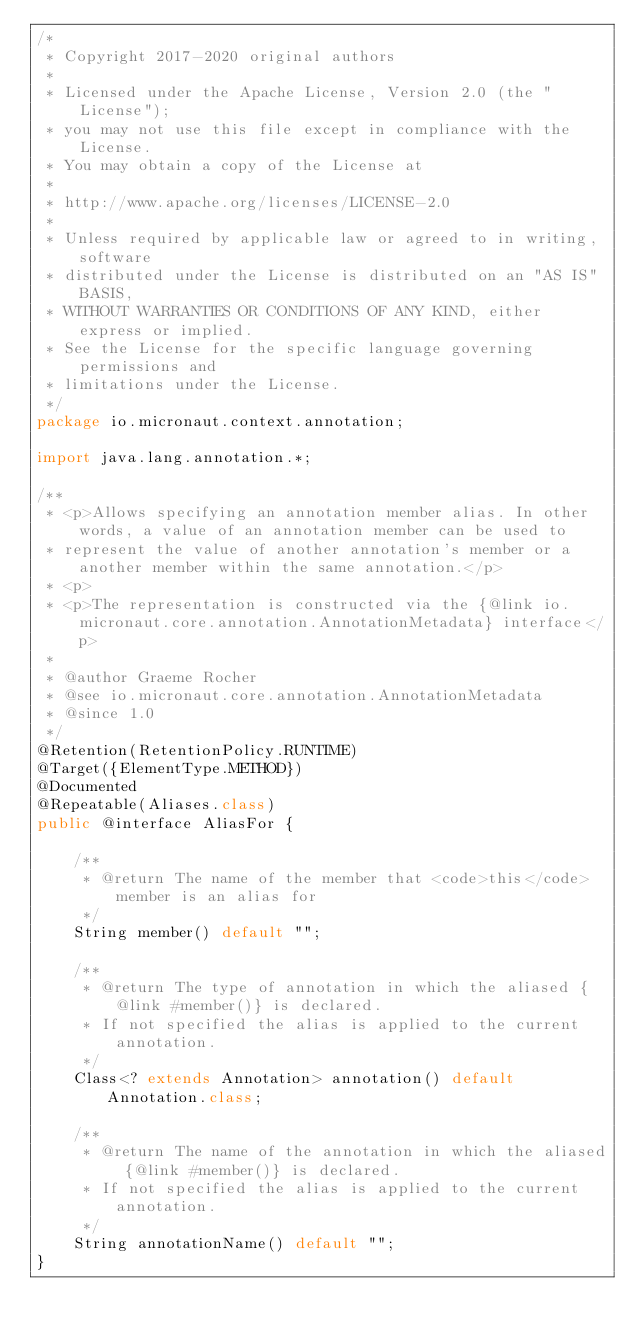<code> <loc_0><loc_0><loc_500><loc_500><_Java_>/*
 * Copyright 2017-2020 original authors
 *
 * Licensed under the Apache License, Version 2.0 (the "License");
 * you may not use this file except in compliance with the License.
 * You may obtain a copy of the License at
 *
 * http://www.apache.org/licenses/LICENSE-2.0
 *
 * Unless required by applicable law or agreed to in writing, software
 * distributed under the License is distributed on an "AS IS" BASIS,
 * WITHOUT WARRANTIES OR CONDITIONS OF ANY KIND, either express or implied.
 * See the License for the specific language governing permissions and
 * limitations under the License.
 */
package io.micronaut.context.annotation;

import java.lang.annotation.*;

/**
 * <p>Allows specifying an annotation member alias. In other words, a value of an annotation member can be used to
 * represent the value of another annotation's member or a another member within the same annotation.</p>
 * <p>
 * <p>The representation is constructed via the {@link io.micronaut.core.annotation.AnnotationMetadata} interface</p>
 *
 * @author Graeme Rocher
 * @see io.micronaut.core.annotation.AnnotationMetadata
 * @since 1.0
 */
@Retention(RetentionPolicy.RUNTIME)
@Target({ElementType.METHOD})
@Documented
@Repeatable(Aliases.class)
public @interface AliasFor {

    /**
     * @return The name of the member that <code>this</code> member is an alias for
     */
    String member() default "";

    /**
     * @return The type of annotation in which the aliased {@link #member()} is declared.
     * If not specified the alias is applied to the current annotation.
     */
    Class<? extends Annotation> annotation() default Annotation.class;

    /**
     * @return The name of the annotation in which the aliased {@link #member()} is declared.
     * If not specified the alias is applied to the current annotation.
     */
    String annotationName() default "";
}
</code> 